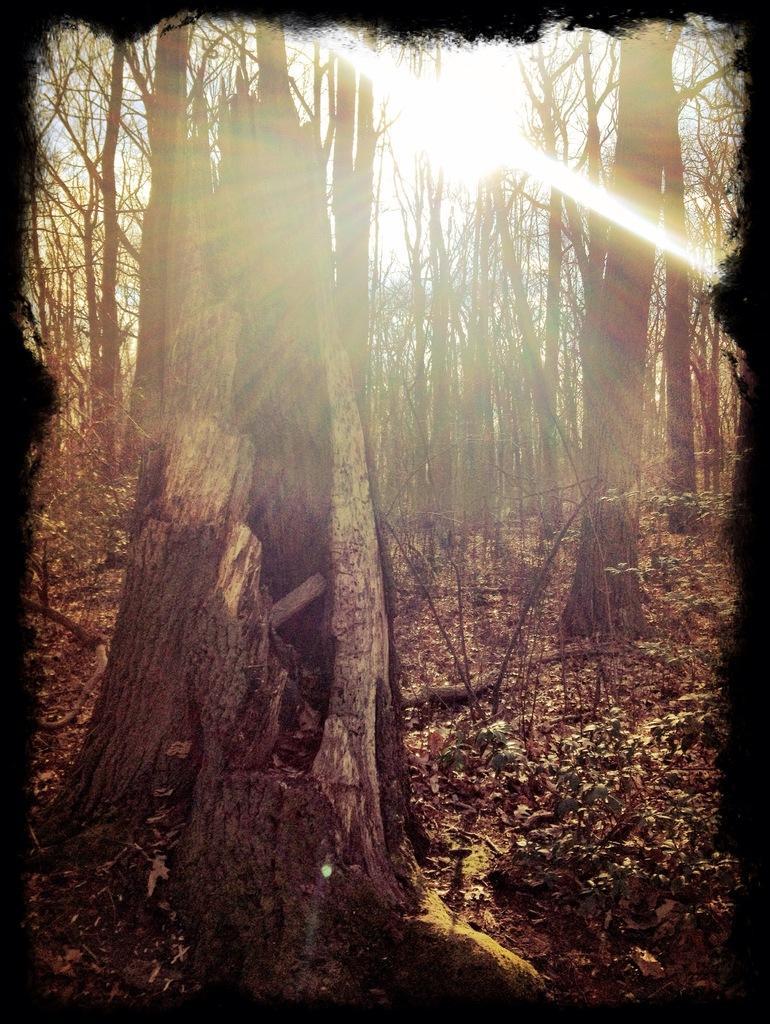In one or two sentences, can you explain what this image depicts? In the image on the ground there are dry leaves. And also there are trees and there is sunlight. 